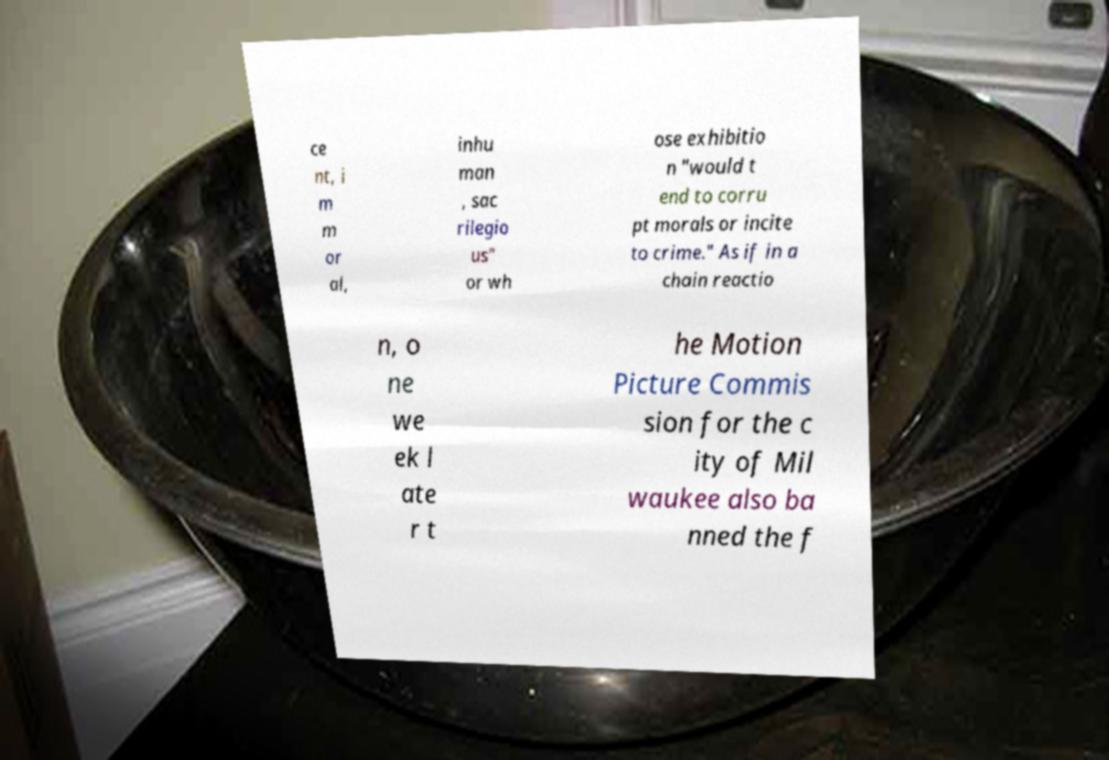Could you assist in decoding the text presented in this image and type it out clearly? ce nt, i m m or al, inhu man , sac rilegio us" or wh ose exhibitio n "would t end to corru pt morals or incite to crime." As if in a chain reactio n, o ne we ek l ate r t he Motion Picture Commis sion for the c ity of Mil waukee also ba nned the f 